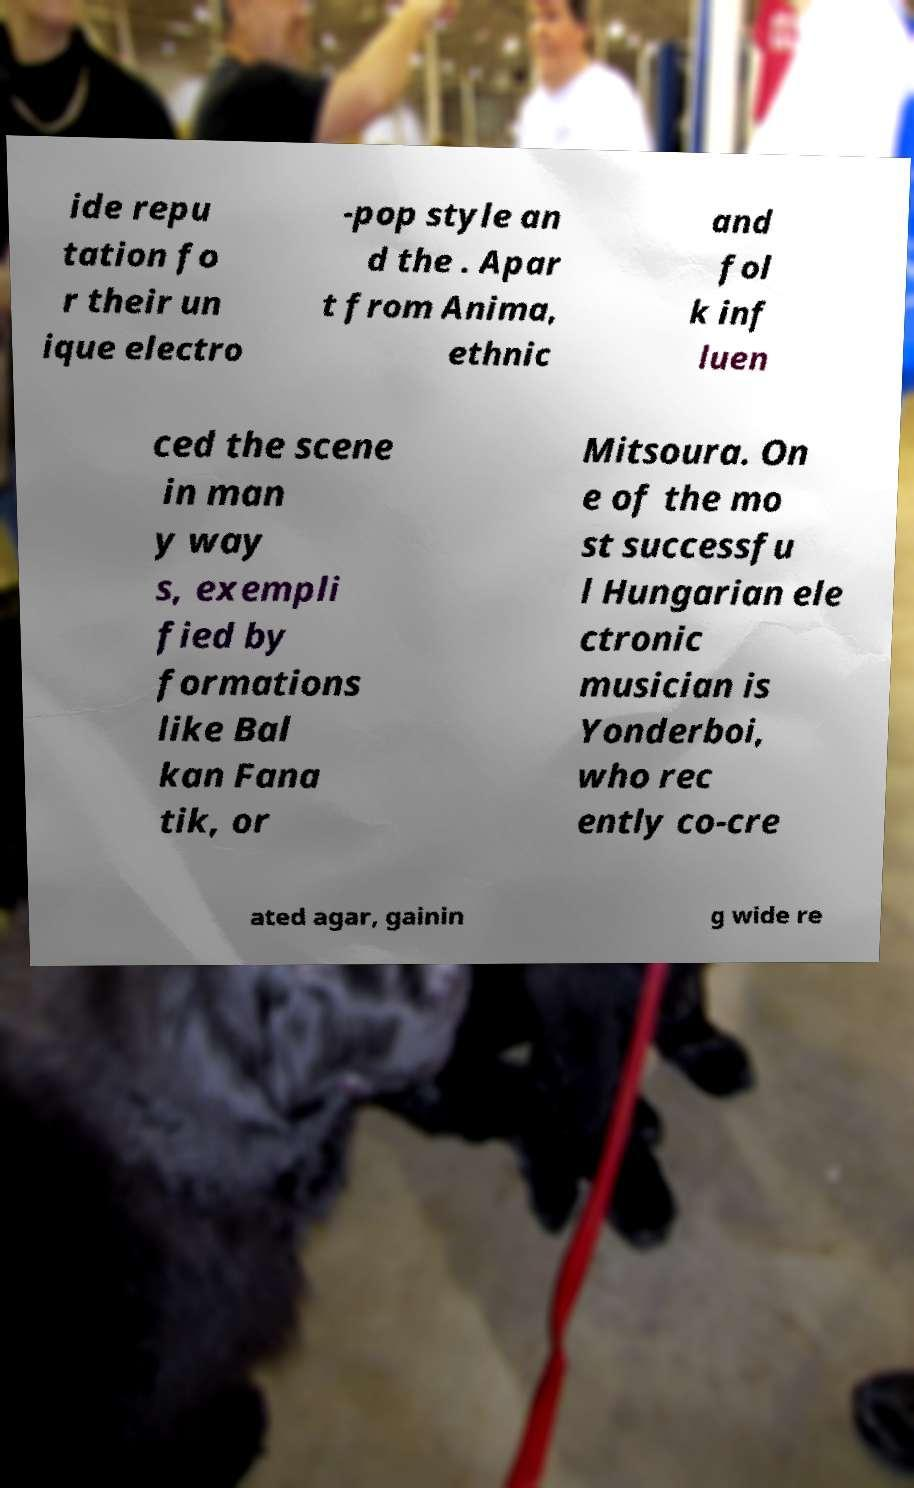I need the written content from this picture converted into text. Can you do that? ide repu tation fo r their un ique electro -pop style an d the . Apar t from Anima, ethnic and fol k inf luen ced the scene in man y way s, exempli fied by formations like Bal kan Fana tik, or Mitsoura. On e of the mo st successfu l Hungarian ele ctronic musician is Yonderboi, who rec ently co-cre ated agar, gainin g wide re 